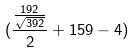Convert formula to latex. <formula><loc_0><loc_0><loc_500><loc_500>( \frac { \frac { 1 9 2 } { \sqrt { 3 9 2 } } } { 2 } + 1 5 9 - 4 )</formula> 